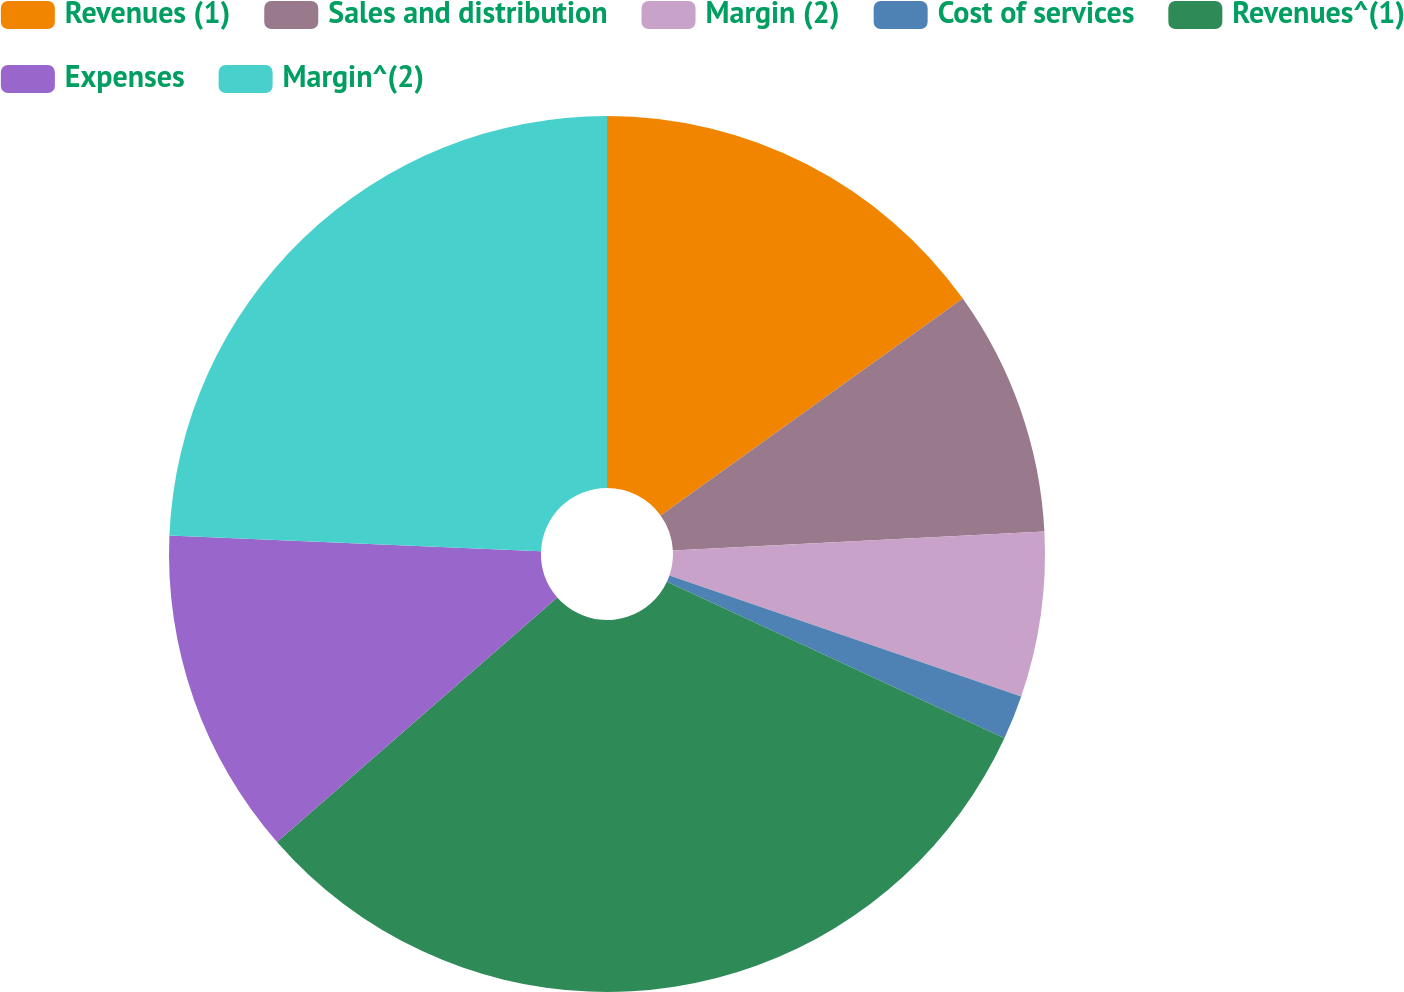<chart> <loc_0><loc_0><loc_500><loc_500><pie_chart><fcel>Revenues (1)<fcel>Sales and distribution<fcel>Margin (2)<fcel>Cost of services<fcel>Revenues^(1)<fcel>Expenses<fcel>Margin^(2)<nl><fcel>15.09%<fcel>9.09%<fcel>6.09%<fcel>1.64%<fcel>31.67%<fcel>12.09%<fcel>24.33%<nl></chart> 